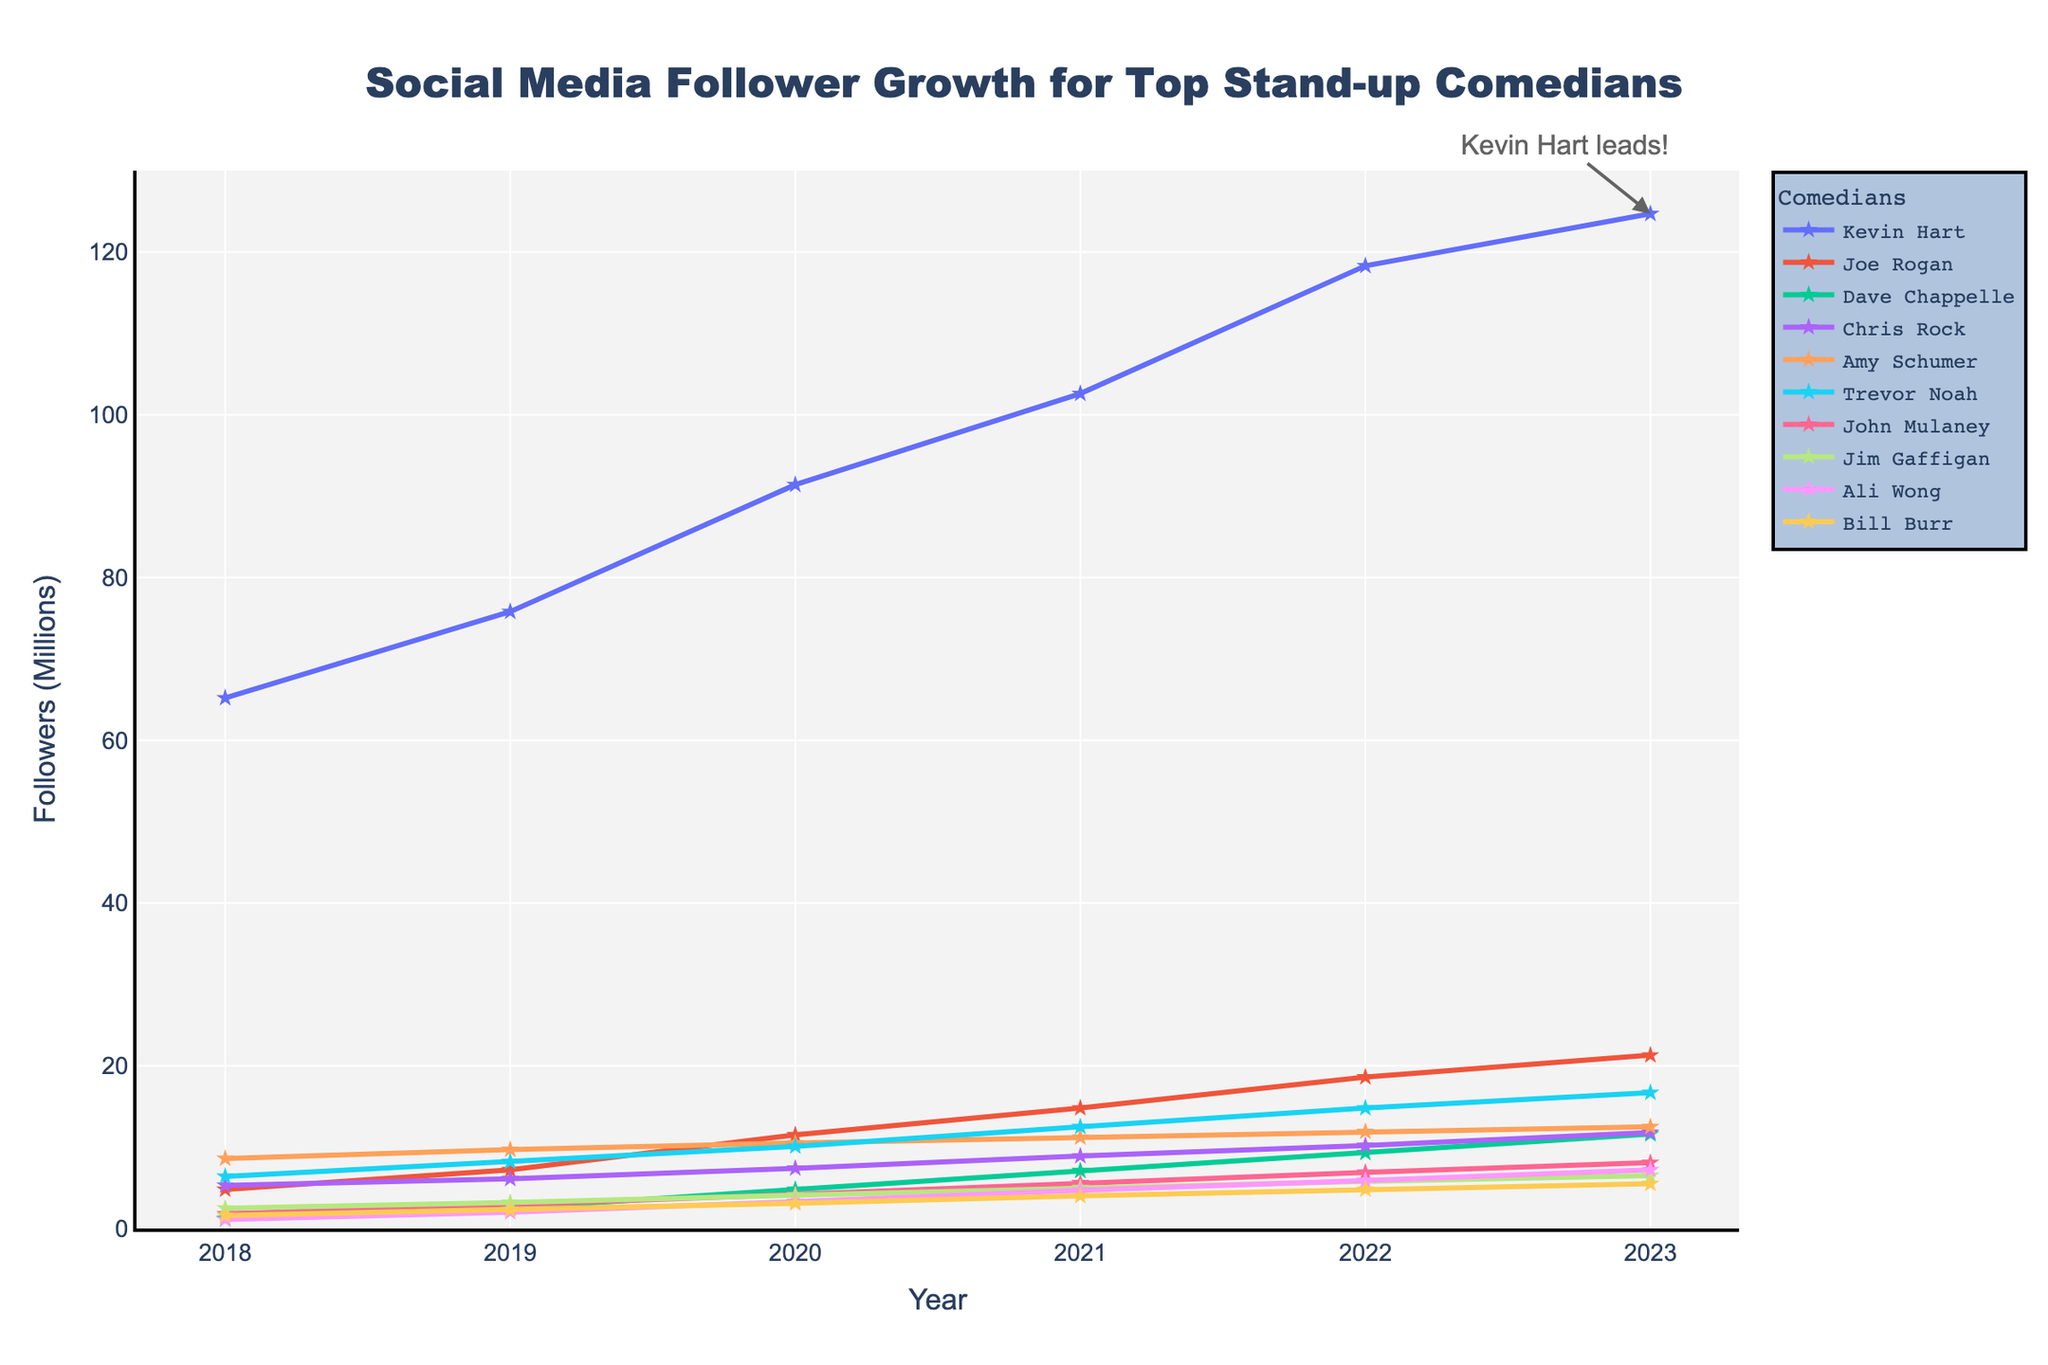What is the total follower growth for Kevin Hart from 2018 to 2023? To find the total follower growth for Kevin Hart from 2018 to 2023, we calculate the difference between his followers in 2023 and 2018. The values are 124.7 million and 65.2 million respectively. Thus, the growth is 124.7 - 65.2 = 59.5 million.
Answer: 59.5 million Which comedian has the highest follower count in 2023? By looking at the plotted line chart, it is evident that Kevin Hart has the highest follower count in 2023, with 124.7 million followers.
Answer: Kevin Hart Between Joe Rogan and Dave Chappelle, who had a larger increase in followers from 2018 to 2023? Calculate the increase in followers for Joe Rogan (21.3 - 4.8 = 16.5 million) and Dave Chappelle (11.6 - 1.2 = 10.4 million). Joe Rogan had a larger increase in followers.
Answer: Joe Rogan In which year did Trevor Noah surpass Jim Gaffigan in followers? Plot the lines for Trevor Noah and Jim Gaffigan and compare their values year by year. Trevor Noah surpassed Jim Gaffigan in 2019 (8.2 million versus 3.2 million).
Answer: 2019 Who had the smallest number of followers in 2018, and what was the count? Referring to the data, Ali Wong had the smallest number of followers in 2018, with only 1.1 million followers.
Answer: Ali Wong, 1.1 million On average, how many followers did John Mulaney gain per year from 2018 to 2023? John Mulaney's total growth in followers over the period is 8.1 - 1.8 = 6.3 million. Over 5 years, the average growth per year is 6.3 / 5 = 1.26 million.
Answer: 1.26 million Compare the follower growth rate between Chris Rock and Amy Schumer from 2021 to 2023. Who had a higher growth rate? Chris Rock's growth from 2021 to 2023 is 11.8 - 8.9 = 2.9 million, and Amy Schumer's growth is 12.5 - 11.2 = 1.3 million. Chris Rock had a higher growth rate with 2.9 million.
Answer: Chris Rock Which two comedians had the closest follower counts in 2023? By examining the follower counts in 2023, Dave Chappelle and Chris Rock had the closest follower counts with 11.6 million and 11.8 million respectively.
Answer: Dave Chappelle and Chris Rock How much did Bill Burr's followers increase by between 2020 and 2023? Bill Burr's followers increased from 3.1 million in 2020 to 5.5 million in 2023. The increase is 5.5 - 3.1 = 2.4 million.
Answer: 2.4 million Which comedian had the steepest increase in followers from 2018 to 2019? By analyzing the slope of the lines between 2018 and 2019, Joe Rogan had the steepest increase, going from 4.8 million to 7.2 million, a gain of 2.4 million.
Answer: Joe Rogan 